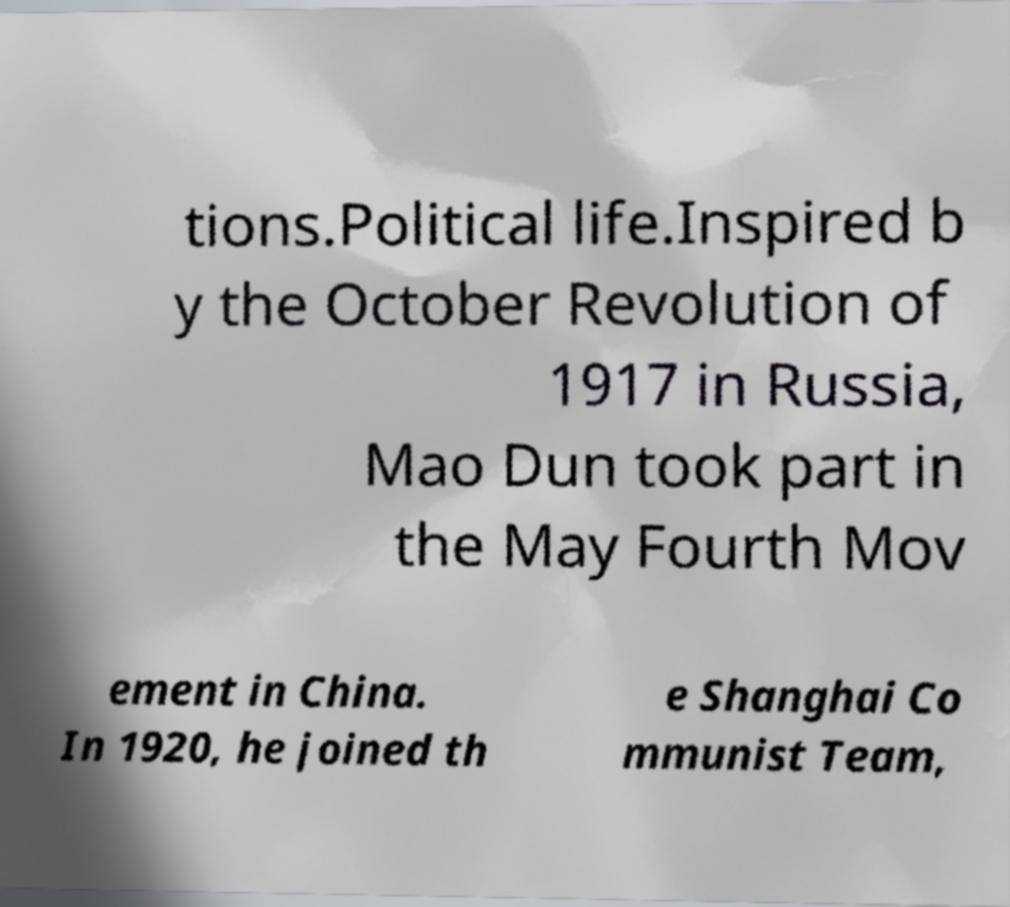Please read and relay the text visible in this image. What does it say? tions.Political life.Inspired b y the October Revolution of 1917 in Russia, Mao Dun took part in the May Fourth Mov ement in China. In 1920, he joined th e Shanghai Co mmunist Team, 